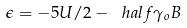Convert formula to latex. <formula><loc_0><loc_0><loc_500><loc_500>\epsilon = - 5 U / 2 - \ h a l f \gamma _ { o } B</formula> 